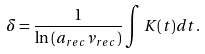Convert formula to latex. <formula><loc_0><loc_0><loc_500><loc_500>\delta = \frac { 1 } { \ln \left ( a _ { r e c } \nu _ { r e c } \right ) } \int K ( t ) d t .</formula> 